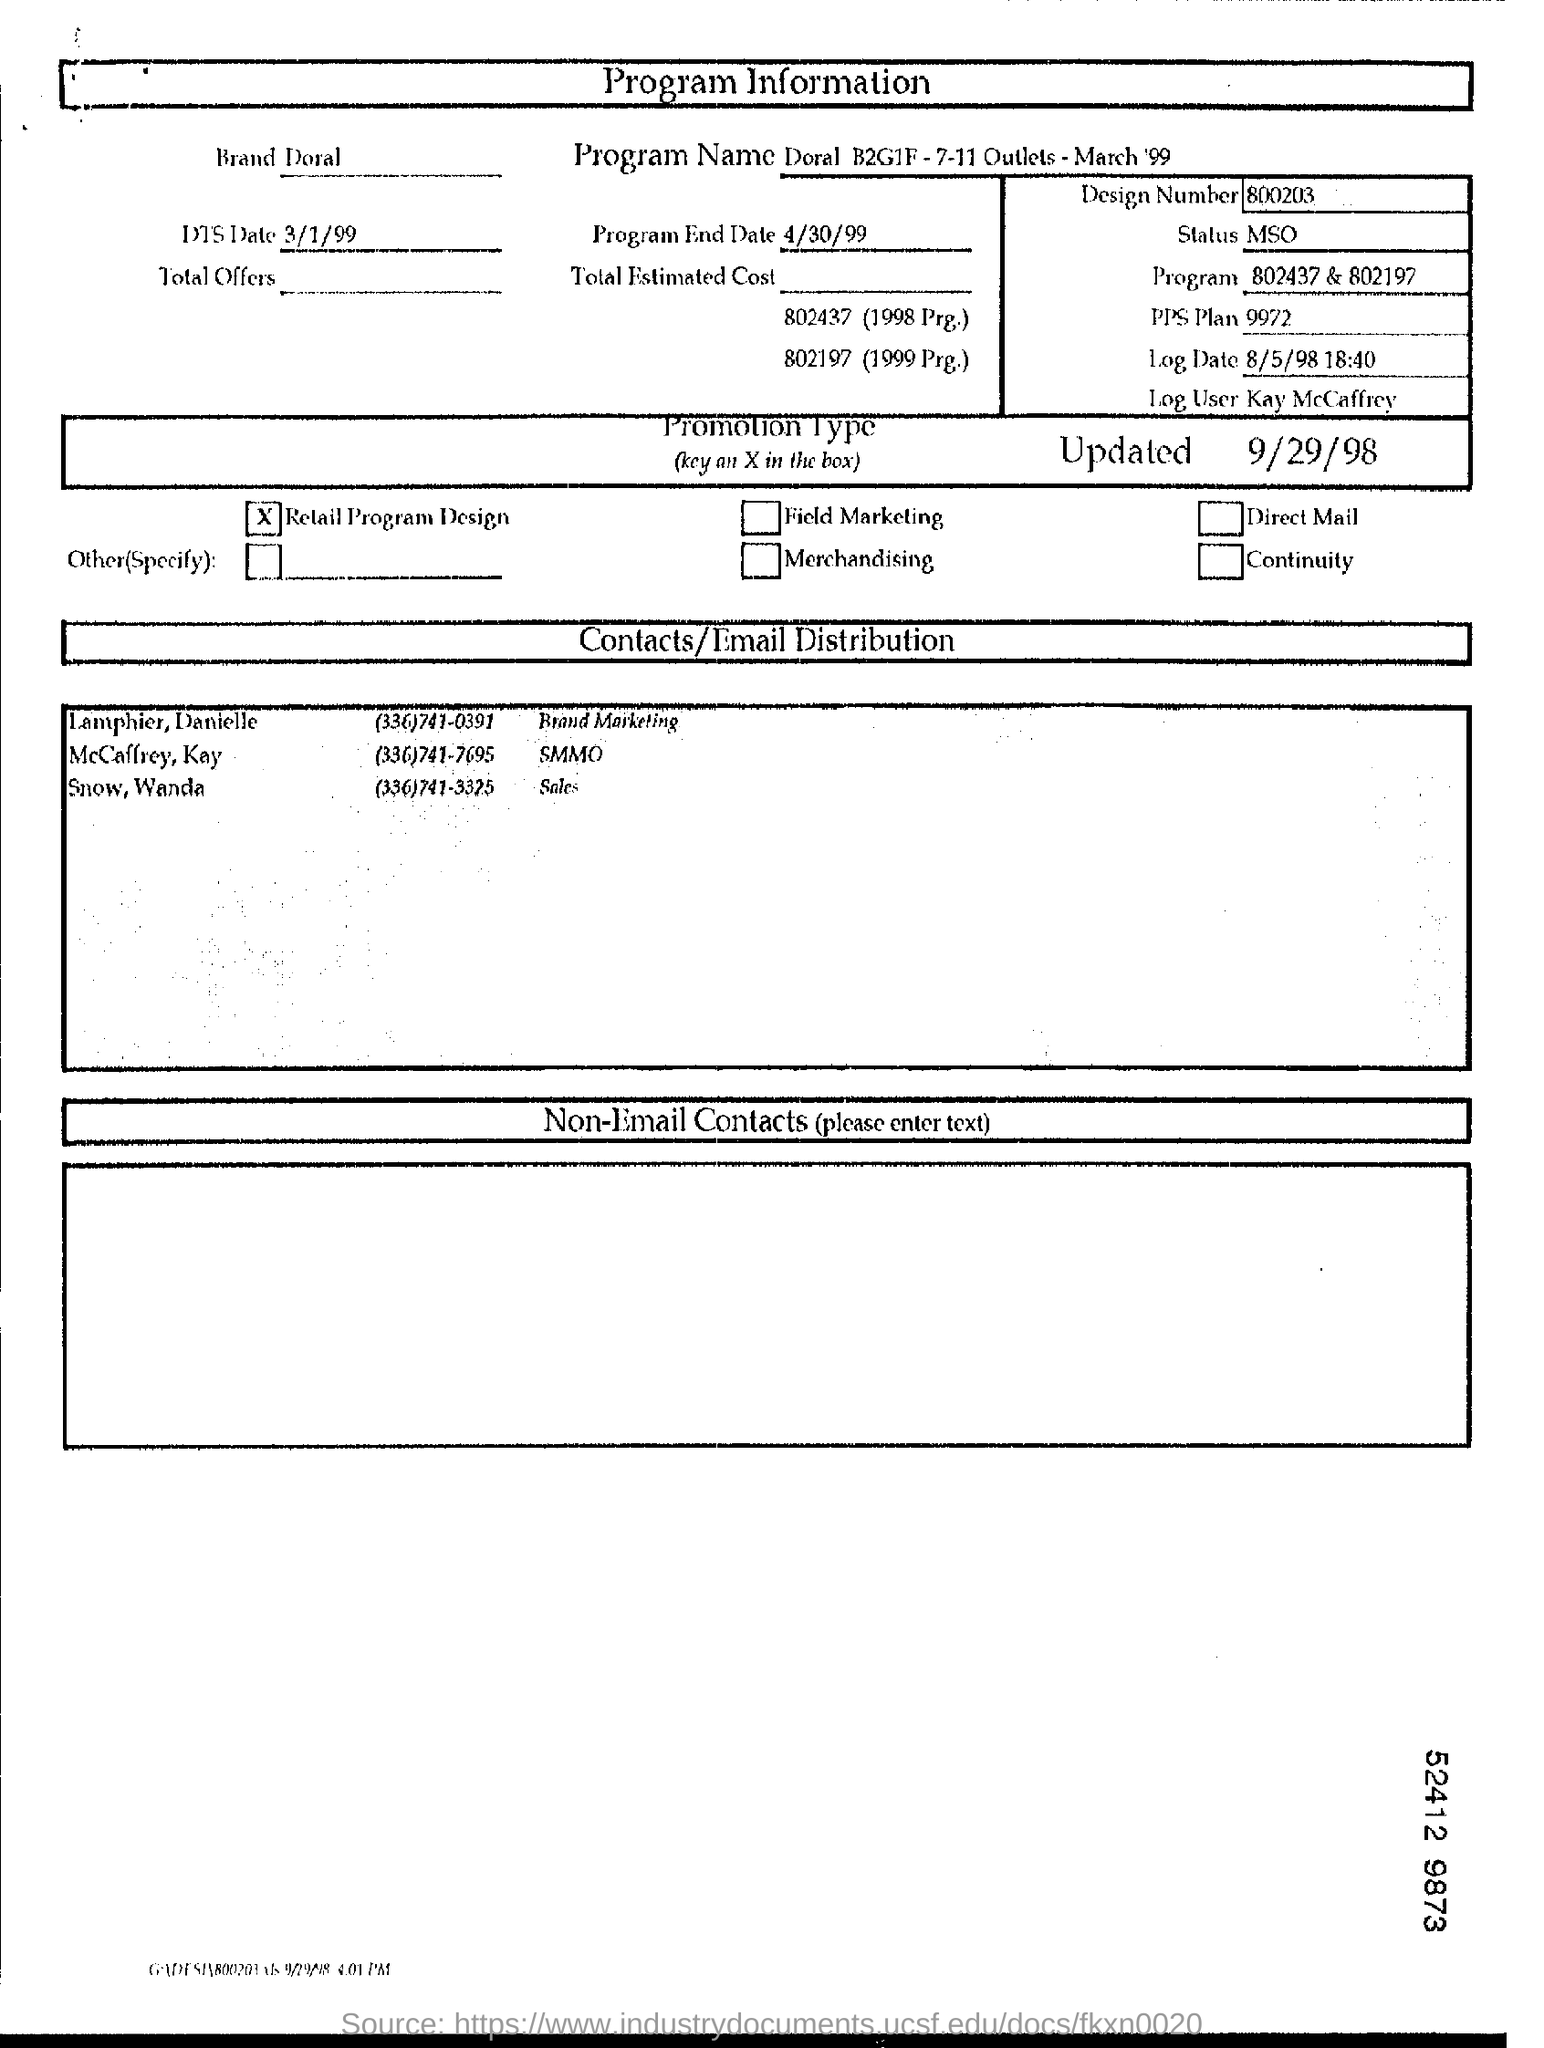Specify some key components in this picture. The document mentions a program named "Doral B2G1F -7-11 Outlets - March '99. According to the document, Kay McCaffrey is the designated log user. The program end date mentioned in the document is April 30, 1999. The brand mentioned in this document is Doral. The design number given in the document is 800203... 